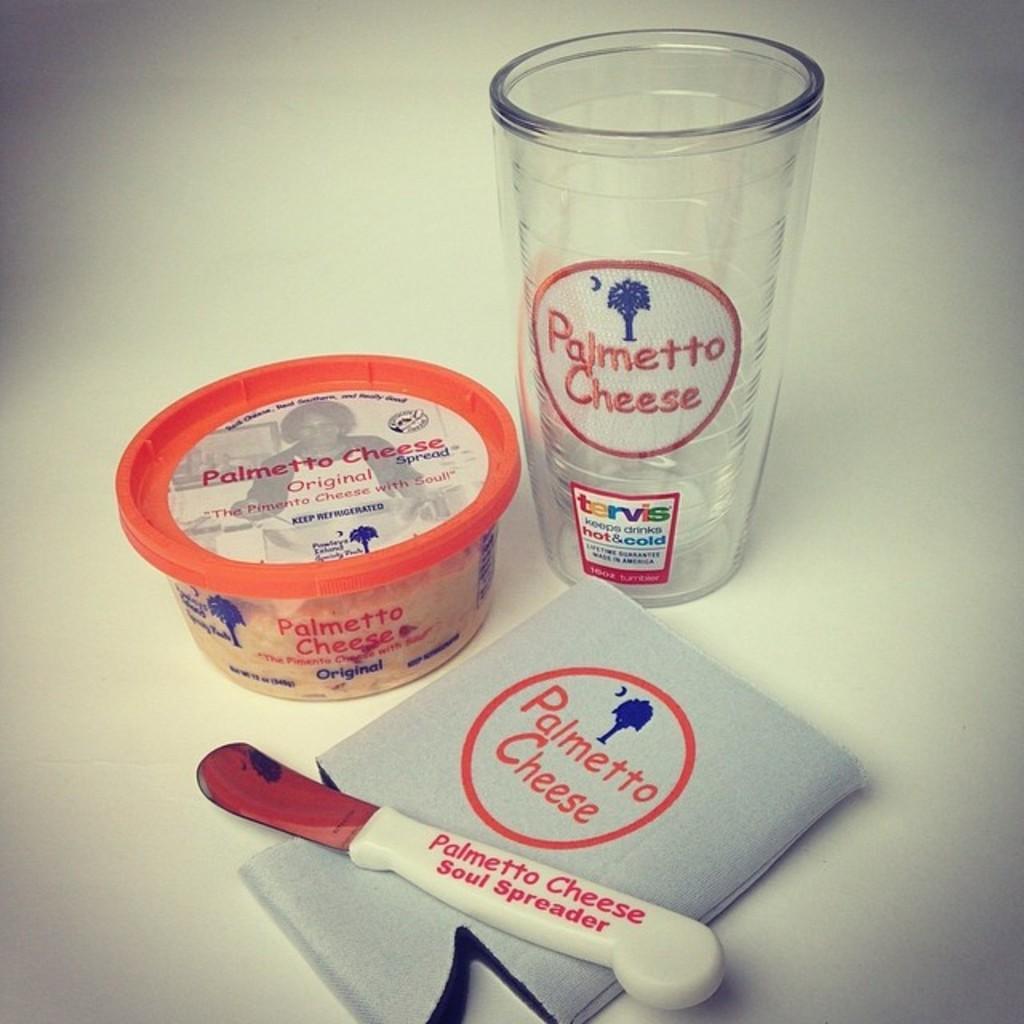How would you summarize this image in a sentence or two? In this image, I can see a box, glass and an object. This is a kind of a knife. The background looks white in color. 